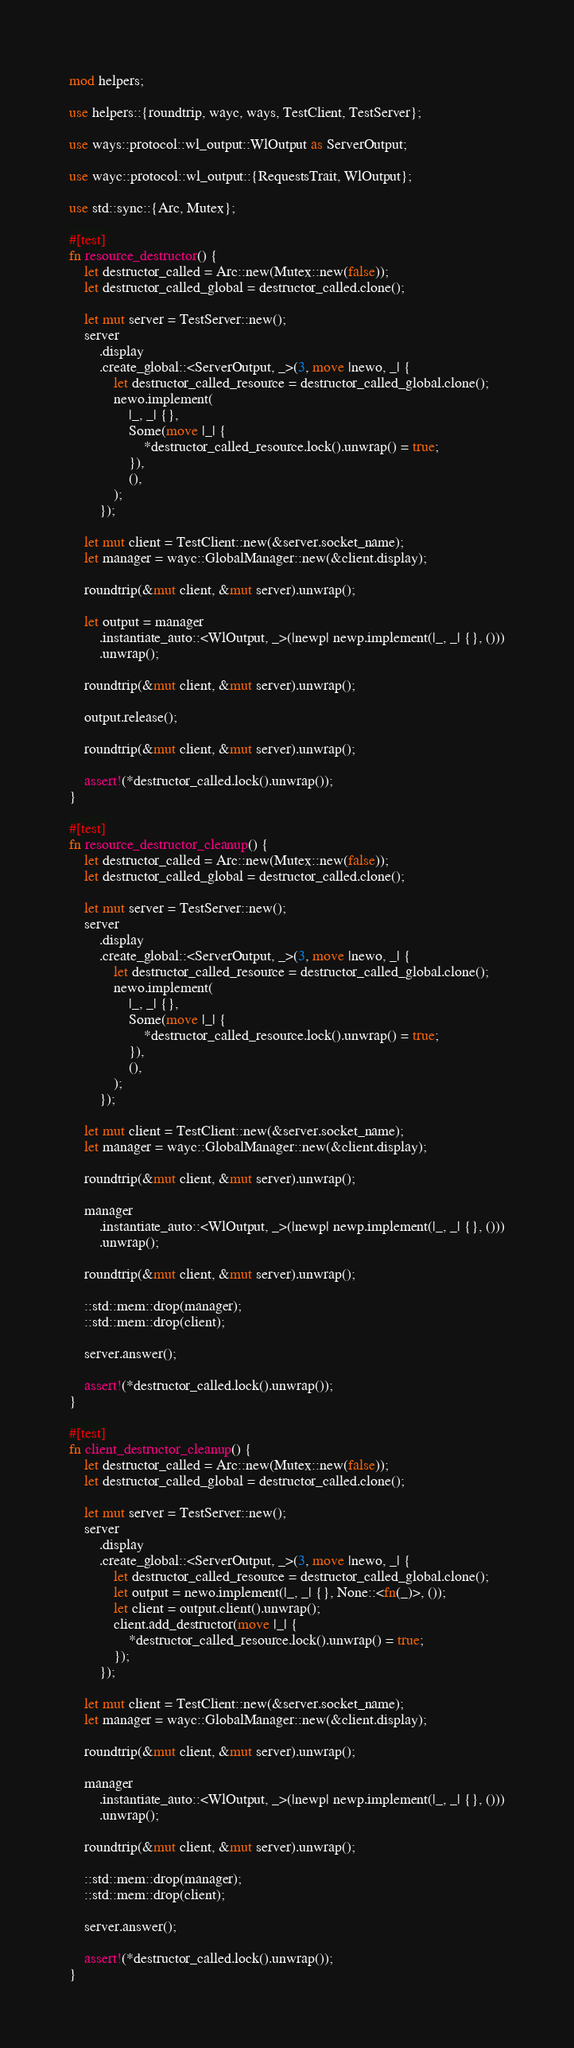Convert code to text. <code><loc_0><loc_0><loc_500><loc_500><_Rust_>mod helpers;

use helpers::{roundtrip, wayc, ways, TestClient, TestServer};

use ways::protocol::wl_output::WlOutput as ServerOutput;

use wayc::protocol::wl_output::{RequestsTrait, WlOutput};

use std::sync::{Arc, Mutex};

#[test]
fn resource_destructor() {
    let destructor_called = Arc::new(Mutex::new(false));
    let destructor_called_global = destructor_called.clone();

    let mut server = TestServer::new();
    server
        .display
        .create_global::<ServerOutput, _>(3, move |newo, _| {
            let destructor_called_resource = destructor_called_global.clone();
            newo.implement(
                |_, _| {},
                Some(move |_| {
                    *destructor_called_resource.lock().unwrap() = true;
                }),
                (),
            );
        });

    let mut client = TestClient::new(&server.socket_name);
    let manager = wayc::GlobalManager::new(&client.display);

    roundtrip(&mut client, &mut server).unwrap();

    let output = manager
        .instantiate_auto::<WlOutput, _>(|newp| newp.implement(|_, _| {}, ()))
        .unwrap();

    roundtrip(&mut client, &mut server).unwrap();

    output.release();

    roundtrip(&mut client, &mut server).unwrap();

    assert!(*destructor_called.lock().unwrap());
}

#[test]
fn resource_destructor_cleanup() {
    let destructor_called = Arc::new(Mutex::new(false));
    let destructor_called_global = destructor_called.clone();

    let mut server = TestServer::new();
    server
        .display
        .create_global::<ServerOutput, _>(3, move |newo, _| {
            let destructor_called_resource = destructor_called_global.clone();
            newo.implement(
                |_, _| {},
                Some(move |_| {
                    *destructor_called_resource.lock().unwrap() = true;
                }),
                (),
            );
        });

    let mut client = TestClient::new(&server.socket_name);
    let manager = wayc::GlobalManager::new(&client.display);

    roundtrip(&mut client, &mut server).unwrap();

    manager
        .instantiate_auto::<WlOutput, _>(|newp| newp.implement(|_, _| {}, ()))
        .unwrap();

    roundtrip(&mut client, &mut server).unwrap();

    ::std::mem::drop(manager);
    ::std::mem::drop(client);

    server.answer();

    assert!(*destructor_called.lock().unwrap());
}

#[test]
fn client_destructor_cleanup() {
    let destructor_called = Arc::new(Mutex::new(false));
    let destructor_called_global = destructor_called.clone();

    let mut server = TestServer::new();
    server
        .display
        .create_global::<ServerOutput, _>(3, move |newo, _| {
            let destructor_called_resource = destructor_called_global.clone();
            let output = newo.implement(|_, _| {}, None::<fn(_)>, ());
            let client = output.client().unwrap();
            client.add_destructor(move |_| {
                *destructor_called_resource.lock().unwrap() = true;
            });
        });

    let mut client = TestClient::new(&server.socket_name);
    let manager = wayc::GlobalManager::new(&client.display);

    roundtrip(&mut client, &mut server).unwrap();

    manager
        .instantiate_auto::<WlOutput, _>(|newp| newp.implement(|_, _| {}, ()))
        .unwrap();

    roundtrip(&mut client, &mut server).unwrap();

    ::std::mem::drop(manager);
    ::std::mem::drop(client);

    server.answer();

    assert!(*destructor_called.lock().unwrap());
}
</code> 